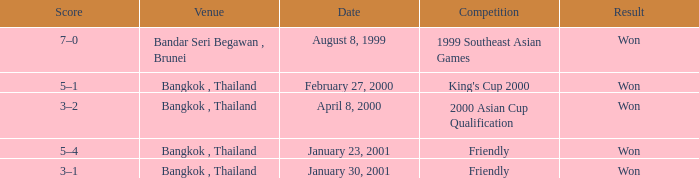What was the result of the game that was played on february 27, 2000? Won. 